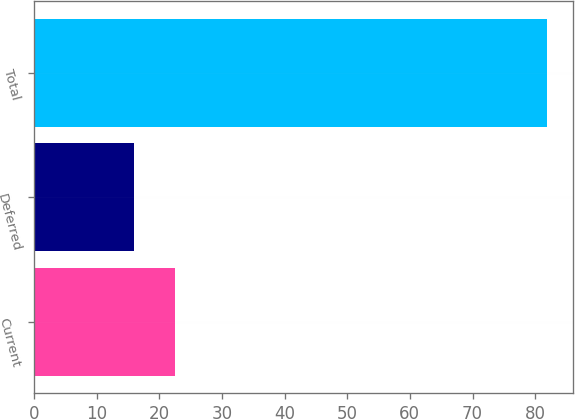Convert chart. <chart><loc_0><loc_0><loc_500><loc_500><bar_chart><fcel>Current<fcel>Deferred<fcel>Total<nl><fcel>22.59<fcel>16<fcel>81.9<nl></chart> 